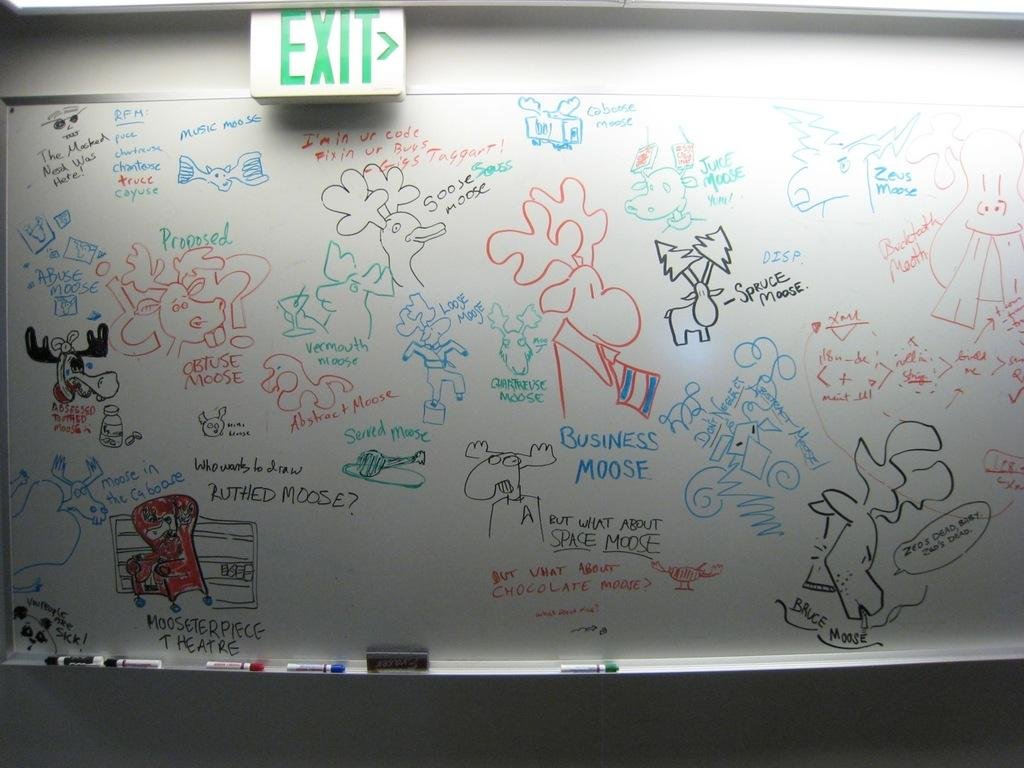<image>
Provide a brief description of the given image. Various writing of the word moose with pictures of moose  in different color marker on a dry erase white board. 